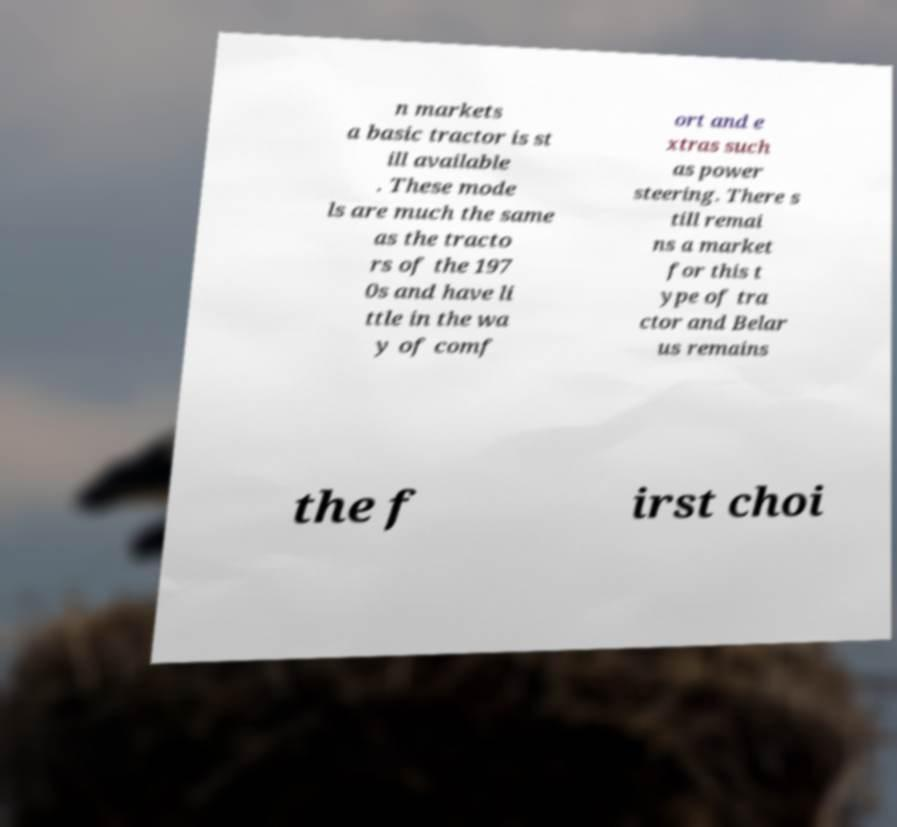Can you read and provide the text displayed in the image?This photo seems to have some interesting text. Can you extract and type it out for me? n markets a basic tractor is st ill available . These mode ls are much the same as the tracto rs of the 197 0s and have li ttle in the wa y of comf ort and e xtras such as power steering. There s till remai ns a market for this t ype of tra ctor and Belar us remains the f irst choi 